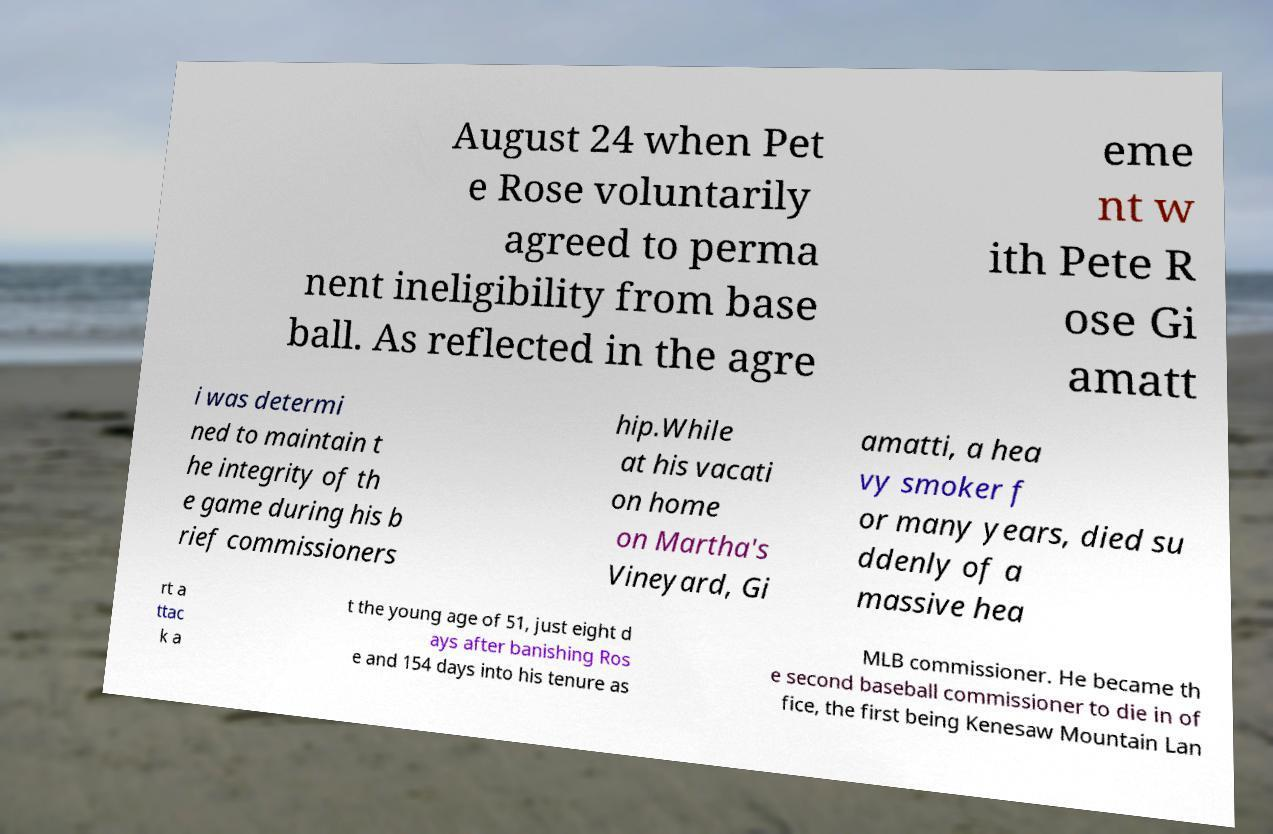Can you read and provide the text displayed in the image?This photo seems to have some interesting text. Can you extract and type it out for me? August 24 when Pet e Rose voluntarily agreed to perma nent ineligibility from base ball. As reflected in the agre eme nt w ith Pete R ose Gi amatt i was determi ned to maintain t he integrity of th e game during his b rief commissioners hip.While at his vacati on home on Martha's Vineyard, Gi amatti, a hea vy smoker f or many years, died su ddenly of a massive hea rt a ttac k a t the young age of 51, just eight d ays after banishing Ros e and 154 days into his tenure as MLB commissioner. He became th e second baseball commissioner to die in of fice, the first being Kenesaw Mountain Lan 